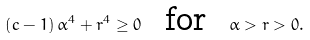<formula> <loc_0><loc_0><loc_500><loc_500>\left ( c - 1 \right ) \alpha ^ { 4 } + r ^ { 4 } \geq 0 \text { \ for \ } \alpha > r > 0 .</formula> 